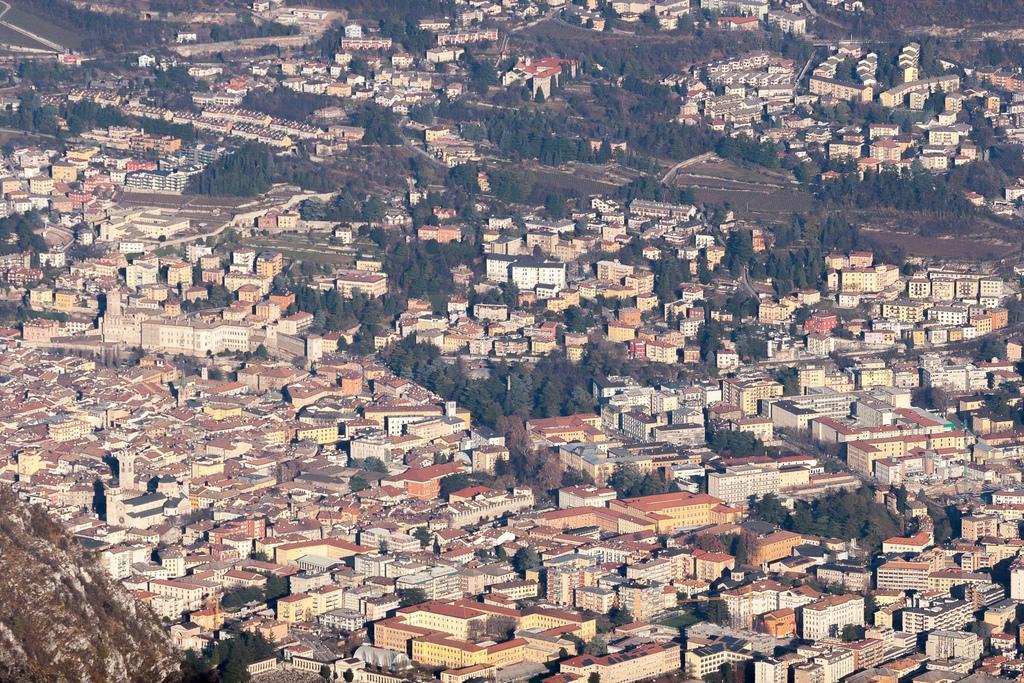Please provide a concise description of this image. This is an aerial view. In this image we can see buildings, trees and ground. 